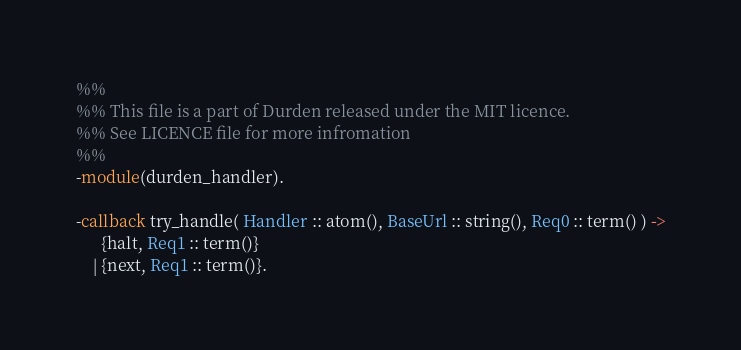<code> <loc_0><loc_0><loc_500><loc_500><_Erlang_>%% 
%% This file is a part of Durden released under the MIT licence.
%% See LICENCE file for more infromation
%% 
-module(durden_handler).

-callback try_handle( Handler :: atom(), BaseUrl :: string(), Req0 :: term() ) ->
	  {halt, Req1 :: term()}
	| {next, Req1 :: term()}.
</code> 